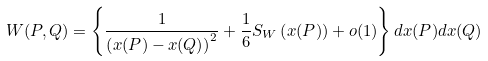Convert formula to latex. <formula><loc_0><loc_0><loc_500><loc_500>W ( P , Q ) = \left \{ \frac { 1 } { \left ( x ( P ) - x ( Q ) \right ) ^ { 2 } } + \frac { 1 } { 6 } S _ { W } \left ( x ( P ) \right ) + o ( 1 ) \right \} d x ( P ) d x ( Q )</formula> 